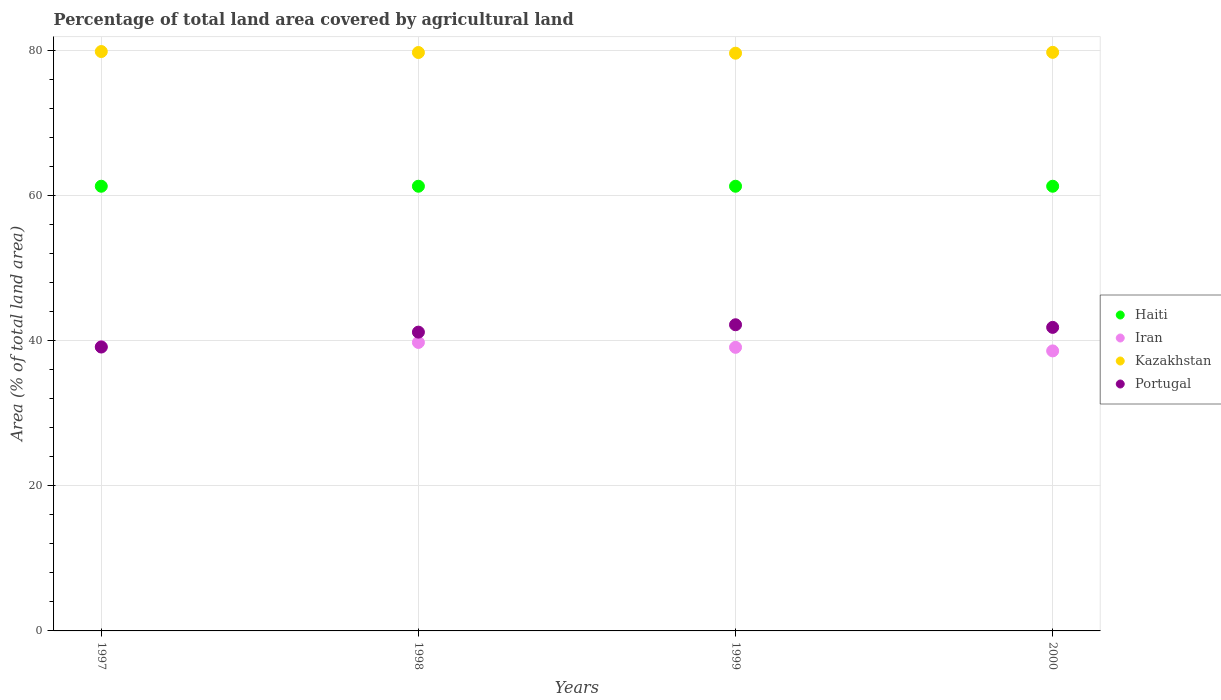How many different coloured dotlines are there?
Make the answer very short. 4. What is the percentage of agricultural land in Haiti in 1999?
Your answer should be very brief. 61.32. Across all years, what is the maximum percentage of agricultural land in Haiti?
Your answer should be very brief. 61.32. Across all years, what is the minimum percentage of agricultural land in Iran?
Provide a succinct answer. 38.61. In which year was the percentage of agricultural land in Iran maximum?
Give a very brief answer. 1998. What is the total percentage of agricultural land in Portugal in the graph?
Make the answer very short. 164.43. What is the difference between the percentage of agricultural land in Haiti in 1997 and that in 1998?
Offer a terse response. 0. What is the difference between the percentage of agricultural land in Haiti in 1997 and the percentage of agricultural land in Iran in 2000?
Provide a succinct answer. 22.71. What is the average percentage of agricultural land in Iran per year?
Offer a very short reply. 39.17. In the year 1998, what is the difference between the percentage of agricultural land in Iran and percentage of agricultural land in Kazakhstan?
Your answer should be very brief. -39.98. What is the ratio of the percentage of agricultural land in Kazakhstan in 1997 to that in 1999?
Give a very brief answer. 1. Is the percentage of agricultural land in Kazakhstan in 1998 less than that in 1999?
Your answer should be very brief. No. Is the difference between the percentage of agricultural land in Iran in 1998 and 1999 greater than the difference between the percentage of agricultural land in Kazakhstan in 1998 and 1999?
Provide a succinct answer. Yes. What is the difference between the highest and the second highest percentage of agricultural land in Iran?
Keep it short and to the point. 0.59. What is the difference between the highest and the lowest percentage of agricultural land in Kazakhstan?
Offer a very short reply. 0.23. In how many years, is the percentage of agricultural land in Haiti greater than the average percentage of agricultural land in Haiti taken over all years?
Give a very brief answer. 0. Is it the case that in every year, the sum of the percentage of agricultural land in Kazakhstan and percentage of agricultural land in Haiti  is greater than the percentage of agricultural land in Portugal?
Your answer should be very brief. Yes. Is the percentage of agricultural land in Portugal strictly greater than the percentage of agricultural land in Iran over the years?
Your answer should be compact. No. How many dotlines are there?
Ensure brevity in your answer.  4. What is the difference between two consecutive major ticks on the Y-axis?
Keep it short and to the point. 20. Does the graph contain any zero values?
Offer a very short reply. No. How many legend labels are there?
Give a very brief answer. 4. How are the legend labels stacked?
Your answer should be very brief. Vertical. What is the title of the graph?
Your answer should be compact. Percentage of total land area covered by agricultural land. Does "Tonga" appear as one of the legend labels in the graph?
Your answer should be compact. No. What is the label or title of the X-axis?
Offer a terse response. Years. What is the label or title of the Y-axis?
Your answer should be compact. Area (% of total land area). What is the Area (% of total land area) in Haiti in 1997?
Your answer should be very brief. 61.32. What is the Area (% of total land area) of Iran in 1997?
Offer a very short reply. 39.2. What is the Area (% of total land area) in Kazakhstan in 1997?
Keep it short and to the point. 79.89. What is the Area (% of total land area) in Portugal in 1997?
Provide a short and direct response. 39.15. What is the Area (% of total land area) of Haiti in 1998?
Provide a short and direct response. 61.32. What is the Area (% of total land area) of Iran in 1998?
Give a very brief answer. 39.78. What is the Area (% of total land area) in Kazakhstan in 1998?
Keep it short and to the point. 79.76. What is the Area (% of total land area) of Portugal in 1998?
Your response must be concise. 41.2. What is the Area (% of total land area) in Haiti in 1999?
Offer a terse response. 61.32. What is the Area (% of total land area) in Iran in 1999?
Make the answer very short. 39.11. What is the Area (% of total land area) in Kazakhstan in 1999?
Your response must be concise. 79.67. What is the Area (% of total land area) in Portugal in 1999?
Make the answer very short. 42.22. What is the Area (% of total land area) of Haiti in 2000?
Ensure brevity in your answer.  61.32. What is the Area (% of total land area) of Iran in 2000?
Give a very brief answer. 38.61. What is the Area (% of total land area) of Kazakhstan in 2000?
Offer a very short reply. 79.78. What is the Area (% of total land area) in Portugal in 2000?
Keep it short and to the point. 41.86. Across all years, what is the maximum Area (% of total land area) of Haiti?
Make the answer very short. 61.32. Across all years, what is the maximum Area (% of total land area) of Iran?
Ensure brevity in your answer.  39.78. Across all years, what is the maximum Area (% of total land area) in Kazakhstan?
Give a very brief answer. 79.89. Across all years, what is the maximum Area (% of total land area) in Portugal?
Keep it short and to the point. 42.22. Across all years, what is the minimum Area (% of total land area) in Haiti?
Give a very brief answer. 61.32. Across all years, what is the minimum Area (% of total land area) of Iran?
Your response must be concise. 38.61. Across all years, what is the minimum Area (% of total land area) in Kazakhstan?
Keep it short and to the point. 79.67. Across all years, what is the minimum Area (% of total land area) of Portugal?
Provide a short and direct response. 39.15. What is the total Area (% of total land area) in Haiti in the graph?
Provide a succinct answer. 245.28. What is the total Area (% of total land area) of Iran in the graph?
Keep it short and to the point. 156.7. What is the total Area (% of total land area) of Kazakhstan in the graph?
Your answer should be compact. 319.11. What is the total Area (% of total land area) of Portugal in the graph?
Your response must be concise. 164.43. What is the difference between the Area (% of total land area) in Iran in 1997 and that in 1998?
Keep it short and to the point. -0.59. What is the difference between the Area (% of total land area) of Kazakhstan in 1997 and that in 1998?
Offer a terse response. 0.13. What is the difference between the Area (% of total land area) of Portugal in 1997 and that in 1998?
Your answer should be compact. -2.05. What is the difference between the Area (% of total land area) of Iran in 1997 and that in 1999?
Keep it short and to the point. 0.09. What is the difference between the Area (% of total land area) of Kazakhstan in 1997 and that in 1999?
Give a very brief answer. 0.23. What is the difference between the Area (% of total land area) in Portugal in 1997 and that in 1999?
Keep it short and to the point. -3.07. What is the difference between the Area (% of total land area) in Haiti in 1997 and that in 2000?
Your answer should be compact. 0. What is the difference between the Area (% of total land area) in Iran in 1997 and that in 2000?
Make the answer very short. 0.58. What is the difference between the Area (% of total land area) of Kazakhstan in 1997 and that in 2000?
Offer a terse response. 0.11. What is the difference between the Area (% of total land area) in Portugal in 1997 and that in 2000?
Ensure brevity in your answer.  -2.71. What is the difference between the Area (% of total land area) of Iran in 1998 and that in 1999?
Your answer should be compact. 0.68. What is the difference between the Area (% of total land area) in Kazakhstan in 1998 and that in 1999?
Your answer should be very brief. 0.09. What is the difference between the Area (% of total land area) in Portugal in 1998 and that in 1999?
Your answer should be very brief. -1.02. What is the difference between the Area (% of total land area) in Iran in 1998 and that in 2000?
Offer a terse response. 1.17. What is the difference between the Area (% of total land area) in Kazakhstan in 1998 and that in 2000?
Keep it short and to the point. -0.02. What is the difference between the Area (% of total land area) of Portugal in 1998 and that in 2000?
Ensure brevity in your answer.  -0.66. What is the difference between the Area (% of total land area) of Haiti in 1999 and that in 2000?
Provide a succinct answer. 0. What is the difference between the Area (% of total land area) of Iran in 1999 and that in 2000?
Ensure brevity in your answer.  0.49. What is the difference between the Area (% of total land area) of Kazakhstan in 1999 and that in 2000?
Offer a very short reply. -0.12. What is the difference between the Area (% of total land area) in Portugal in 1999 and that in 2000?
Keep it short and to the point. 0.36. What is the difference between the Area (% of total land area) of Haiti in 1997 and the Area (% of total land area) of Iran in 1998?
Your answer should be very brief. 21.54. What is the difference between the Area (% of total land area) in Haiti in 1997 and the Area (% of total land area) in Kazakhstan in 1998?
Keep it short and to the point. -18.44. What is the difference between the Area (% of total land area) of Haiti in 1997 and the Area (% of total land area) of Portugal in 1998?
Keep it short and to the point. 20.12. What is the difference between the Area (% of total land area) in Iran in 1997 and the Area (% of total land area) in Kazakhstan in 1998?
Your answer should be very brief. -40.56. What is the difference between the Area (% of total land area) of Iran in 1997 and the Area (% of total land area) of Portugal in 1998?
Your answer should be very brief. -2.01. What is the difference between the Area (% of total land area) in Kazakhstan in 1997 and the Area (% of total land area) in Portugal in 1998?
Offer a terse response. 38.69. What is the difference between the Area (% of total land area) in Haiti in 1997 and the Area (% of total land area) in Iran in 1999?
Provide a short and direct response. 22.21. What is the difference between the Area (% of total land area) in Haiti in 1997 and the Area (% of total land area) in Kazakhstan in 1999?
Your answer should be compact. -18.35. What is the difference between the Area (% of total land area) of Haiti in 1997 and the Area (% of total land area) of Portugal in 1999?
Give a very brief answer. 19.1. What is the difference between the Area (% of total land area) in Iran in 1997 and the Area (% of total land area) in Kazakhstan in 1999?
Make the answer very short. -40.47. What is the difference between the Area (% of total land area) in Iran in 1997 and the Area (% of total land area) in Portugal in 1999?
Keep it short and to the point. -3.02. What is the difference between the Area (% of total land area) in Kazakhstan in 1997 and the Area (% of total land area) in Portugal in 1999?
Your response must be concise. 37.68. What is the difference between the Area (% of total land area) in Haiti in 1997 and the Area (% of total land area) in Iran in 2000?
Your answer should be compact. 22.71. What is the difference between the Area (% of total land area) in Haiti in 1997 and the Area (% of total land area) in Kazakhstan in 2000?
Make the answer very short. -18.46. What is the difference between the Area (% of total land area) in Haiti in 1997 and the Area (% of total land area) in Portugal in 2000?
Keep it short and to the point. 19.46. What is the difference between the Area (% of total land area) in Iran in 1997 and the Area (% of total land area) in Kazakhstan in 2000?
Your answer should be compact. -40.59. What is the difference between the Area (% of total land area) in Iran in 1997 and the Area (% of total land area) in Portugal in 2000?
Keep it short and to the point. -2.66. What is the difference between the Area (% of total land area) of Kazakhstan in 1997 and the Area (% of total land area) of Portugal in 2000?
Ensure brevity in your answer.  38.04. What is the difference between the Area (% of total land area) of Haiti in 1998 and the Area (% of total land area) of Iran in 1999?
Keep it short and to the point. 22.21. What is the difference between the Area (% of total land area) in Haiti in 1998 and the Area (% of total land area) in Kazakhstan in 1999?
Provide a short and direct response. -18.35. What is the difference between the Area (% of total land area) in Haiti in 1998 and the Area (% of total land area) in Portugal in 1999?
Provide a short and direct response. 19.1. What is the difference between the Area (% of total land area) in Iran in 1998 and the Area (% of total land area) in Kazakhstan in 1999?
Offer a terse response. -39.88. What is the difference between the Area (% of total land area) in Iran in 1998 and the Area (% of total land area) in Portugal in 1999?
Ensure brevity in your answer.  -2.44. What is the difference between the Area (% of total land area) of Kazakhstan in 1998 and the Area (% of total land area) of Portugal in 1999?
Your answer should be very brief. 37.54. What is the difference between the Area (% of total land area) in Haiti in 1998 and the Area (% of total land area) in Iran in 2000?
Make the answer very short. 22.71. What is the difference between the Area (% of total land area) of Haiti in 1998 and the Area (% of total land area) of Kazakhstan in 2000?
Offer a very short reply. -18.46. What is the difference between the Area (% of total land area) of Haiti in 1998 and the Area (% of total land area) of Portugal in 2000?
Your answer should be compact. 19.46. What is the difference between the Area (% of total land area) of Iran in 1998 and the Area (% of total land area) of Kazakhstan in 2000?
Your answer should be very brief. -40. What is the difference between the Area (% of total land area) of Iran in 1998 and the Area (% of total land area) of Portugal in 2000?
Your answer should be compact. -2.08. What is the difference between the Area (% of total land area) of Kazakhstan in 1998 and the Area (% of total land area) of Portugal in 2000?
Offer a terse response. 37.9. What is the difference between the Area (% of total land area) in Haiti in 1999 and the Area (% of total land area) in Iran in 2000?
Make the answer very short. 22.71. What is the difference between the Area (% of total land area) of Haiti in 1999 and the Area (% of total land area) of Kazakhstan in 2000?
Keep it short and to the point. -18.46. What is the difference between the Area (% of total land area) in Haiti in 1999 and the Area (% of total land area) in Portugal in 2000?
Make the answer very short. 19.46. What is the difference between the Area (% of total land area) of Iran in 1999 and the Area (% of total land area) of Kazakhstan in 2000?
Provide a short and direct response. -40.68. What is the difference between the Area (% of total land area) in Iran in 1999 and the Area (% of total land area) in Portugal in 2000?
Provide a succinct answer. -2.75. What is the difference between the Area (% of total land area) in Kazakhstan in 1999 and the Area (% of total land area) in Portugal in 2000?
Make the answer very short. 37.81. What is the average Area (% of total land area) in Haiti per year?
Your answer should be very brief. 61.32. What is the average Area (% of total land area) of Iran per year?
Give a very brief answer. 39.17. What is the average Area (% of total land area) in Kazakhstan per year?
Your answer should be compact. 79.78. What is the average Area (% of total land area) in Portugal per year?
Give a very brief answer. 41.11. In the year 1997, what is the difference between the Area (% of total land area) in Haiti and Area (% of total land area) in Iran?
Give a very brief answer. 22.13. In the year 1997, what is the difference between the Area (% of total land area) of Haiti and Area (% of total land area) of Kazakhstan?
Keep it short and to the point. -18.57. In the year 1997, what is the difference between the Area (% of total land area) of Haiti and Area (% of total land area) of Portugal?
Provide a succinct answer. 22.17. In the year 1997, what is the difference between the Area (% of total land area) of Iran and Area (% of total land area) of Kazakhstan?
Offer a very short reply. -40.7. In the year 1997, what is the difference between the Area (% of total land area) in Iran and Area (% of total land area) in Portugal?
Make the answer very short. 0.05. In the year 1997, what is the difference between the Area (% of total land area) of Kazakhstan and Area (% of total land area) of Portugal?
Offer a very short reply. 40.75. In the year 1998, what is the difference between the Area (% of total land area) in Haiti and Area (% of total land area) in Iran?
Provide a succinct answer. 21.54. In the year 1998, what is the difference between the Area (% of total land area) of Haiti and Area (% of total land area) of Kazakhstan?
Your response must be concise. -18.44. In the year 1998, what is the difference between the Area (% of total land area) of Haiti and Area (% of total land area) of Portugal?
Your answer should be compact. 20.12. In the year 1998, what is the difference between the Area (% of total land area) of Iran and Area (% of total land area) of Kazakhstan?
Offer a terse response. -39.98. In the year 1998, what is the difference between the Area (% of total land area) of Iran and Area (% of total land area) of Portugal?
Keep it short and to the point. -1.42. In the year 1998, what is the difference between the Area (% of total land area) of Kazakhstan and Area (% of total land area) of Portugal?
Your answer should be very brief. 38.56. In the year 1999, what is the difference between the Area (% of total land area) of Haiti and Area (% of total land area) of Iran?
Make the answer very short. 22.21. In the year 1999, what is the difference between the Area (% of total land area) of Haiti and Area (% of total land area) of Kazakhstan?
Make the answer very short. -18.35. In the year 1999, what is the difference between the Area (% of total land area) of Haiti and Area (% of total land area) of Portugal?
Provide a short and direct response. 19.1. In the year 1999, what is the difference between the Area (% of total land area) of Iran and Area (% of total land area) of Kazakhstan?
Your answer should be compact. -40.56. In the year 1999, what is the difference between the Area (% of total land area) of Iran and Area (% of total land area) of Portugal?
Provide a short and direct response. -3.11. In the year 1999, what is the difference between the Area (% of total land area) in Kazakhstan and Area (% of total land area) in Portugal?
Your answer should be very brief. 37.45. In the year 2000, what is the difference between the Area (% of total land area) of Haiti and Area (% of total land area) of Iran?
Keep it short and to the point. 22.71. In the year 2000, what is the difference between the Area (% of total land area) of Haiti and Area (% of total land area) of Kazakhstan?
Offer a terse response. -18.46. In the year 2000, what is the difference between the Area (% of total land area) of Haiti and Area (% of total land area) of Portugal?
Offer a very short reply. 19.46. In the year 2000, what is the difference between the Area (% of total land area) in Iran and Area (% of total land area) in Kazakhstan?
Your answer should be very brief. -41.17. In the year 2000, what is the difference between the Area (% of total land area) in Iran and Area (% of total land area) in Portugal?
Ensure brevity in your answer.  -3.24. In the year 2000, what is the difference between the Area (% of total land area) in Kazakhstan and Area (% of total land area) in Portugal?
Offer a terse response. 37.93. What is the ratio of the Area (% of total land area) in Haiti in 1997 to that in 1998?
Provide a short and direct response. 1. What is the ratio of the Area (% of total land area) of Iran in 1997 to that in 1998?
Your response must be concise. 0.99. What is the ratio of the Area (% of total land area) of Portugal in 1997 to that in 1998?
Provide a short and direct response. 0.95. What is the ratio of the Area (% of total land area) in Portugal in 1997 to that in 1999?
Keep it short and to the point. 0.93. What is the ratio of the Area (% of total land area) of Iran in 1997 to that in 2000?
Ensure brevity in your answer.  1.02. What is the ratio of the Area (% of total land area) in Portugal in 1997 to that in 2000?
Your answer should be compact. 0.94. What is the ratio of the Area (% of total land area) of Haiti in 1998 to that in 1999?
Offer a very short reply. 1. What is the ratio of the Area (% of total land area) in Iran in 1998 to that in 1999?
Ensure brevity in your answer.  1.02. What is the ratio of the Area (% of total land area) of Kazakhstan in 1998 to that in 1999?
Keep it short and to the point. 1. What is the ratio of the Area (% of total land area) of Portugal in 1998 to that in 1999?
Give a very brief answer. 0.98. What is the ratio of the Area (% of total land area) of Haiti in 1998 to that in 2000?
Ensure brevity in your answer.  1. What is the ratio of the Area (% of total land area) of Iran in 1998 to that in 2000?
Offer a very short reply. 1.03. What is the ratio of the Area (% of total land area) in Portugal in 1998 to that in 2000?
Your answer should be very brief. 0.98. What is the ratio of the Area (% of total land area) in Iran in 1999 to that in 2000?
Ensure brevity in your answer.  1.01. What is the ratio of the Area (% of total land area) of Kazakhstan in 1999 to that in 2000?
Your answer should be very brief. 1. What is the ratio of the Area (% of total land area) in Portugal in 1999 to that in 2000?
Provide a succinct answer. 1.01. What is the difference between the highest and the second highest Area (% of total land area) in Iran?
Ensure brevity in your answer.  0.59. What is the difference between the highest and the second highest Area (% of total land area) of Kazakhstan?
Offer a very short reply. 0.11. What is the difference between the highest and the second highest Area (% of total land area) of Portugal?
Keep it short and to the point. 0.36. What is the difference between the highest and the lowest Area (% of total land area) of Iran?
Keep it short and to the point. 1.17. What is the difference between the highest and the lowest Area (% of total land area) of Kazakhstan?
Your answer should be very brief. 0.23. What is the difference between the highest and the lowest Area (% of total land area) of Portugal?
Ensure brevity in your answer.  3.07. 